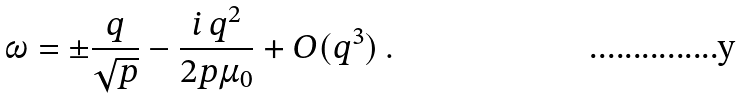<formula> <loc_0><loc_0><loc_500><loc_500>\omega = \pm \frac { q } { \sqrt { p } } - \frac { i \, q ^ { 2 } } { 2 p \mu _ { 0 } } + O ( q ^ { 3 } ) \, .</formula> 